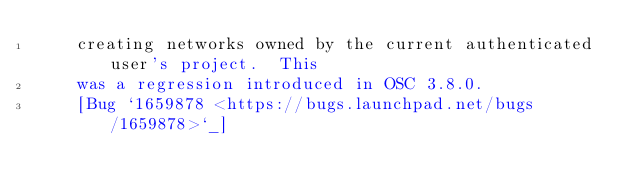<code> <loc_0><loc_0><loc_500><loc_500><_YAML_>    creating networks owned by the current authenticated user's project.  This
    was a regression introduced in OSC 3.8.0.
    [Bug `1659878 <https://bugs.launchpad.net/bugs/1659878>`_]
</code> 